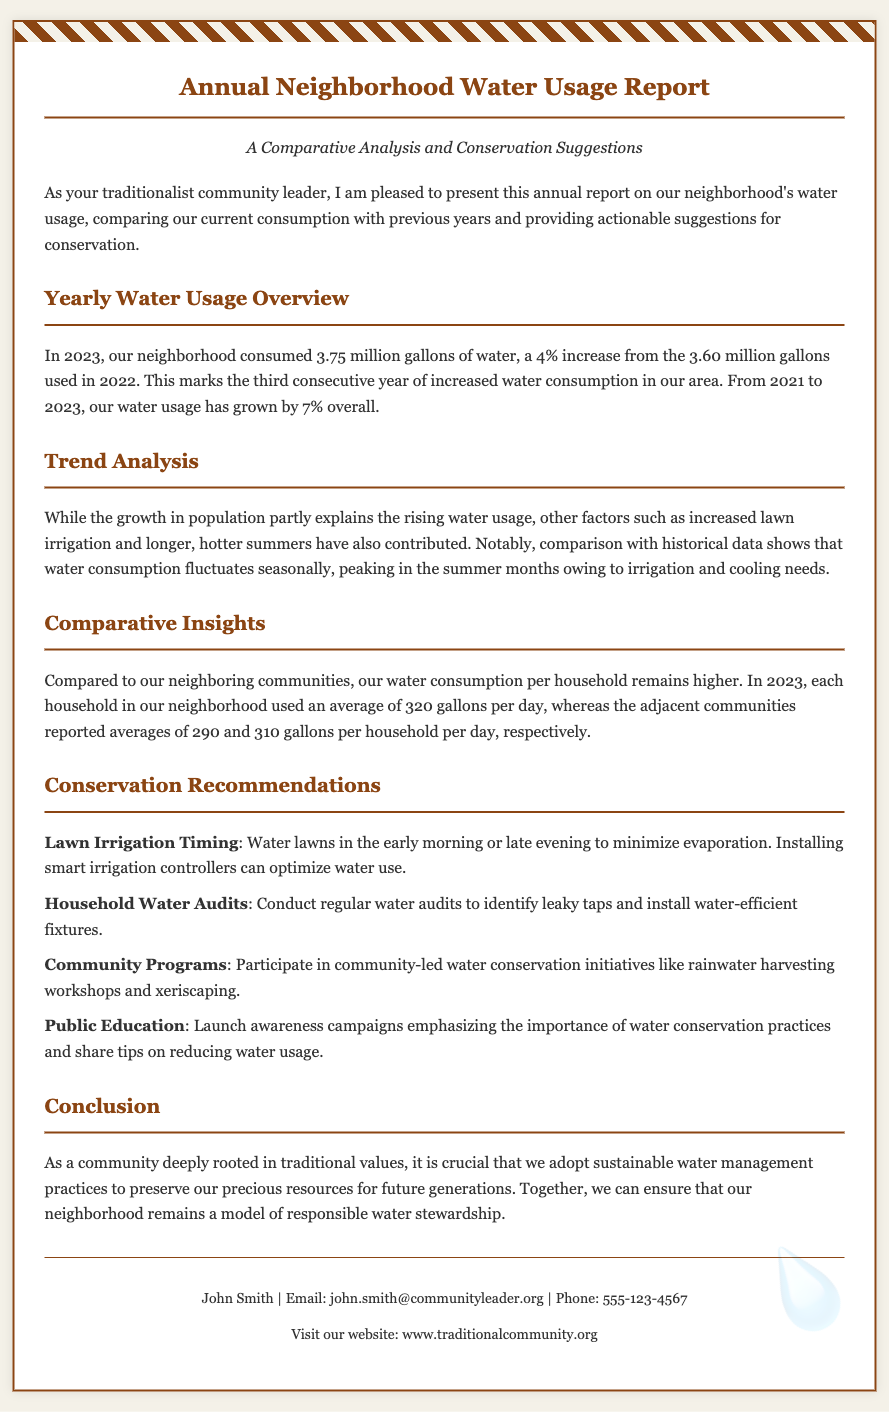What was the total water consumption in 2023? The document states that the neighborhood consumed 3.75 million gallons of water in 2023.
Answer: 3.75 million gallons What was the percentage increase in water usage from 2022 to 2023? The report indicates a 4% increase in water usage compared to 2022.
Answer: 4% How many gallons per day did each household use in 2023? Each household in the neighborhood used an average of 320 gallons per day in 2023.
Answer: 320 gallons What are the recommendations for lawn irrigation timing? The document suggests watering lawns in the early morning or late evening to minimize evaporation.
Answer: Early morning or late evening Who is the author of the report? The footer of the document names John Smith as the author.
Answer: John Smith What is the overall percentage growth in water usage from 2021 to 2023? The report mentions a 7% overall growth in water usage from 2021 to 2023.
Answer: 7% What is one of the conservation recommendations mentioned? The document lists conducting regular water audits as one of the recommendations.
Answer: Regular water audits How does the neighborhood's water usage compare to neighboring communities? The report indicates that the neighborhood's average usage is higher compared to adjacent communities.
Answer: Higher What type of report is this document classified as? The document presents itself as an Annual Neighborhood Water Usage Report.
Answer: Annual Neighborhood Water Usage Report 